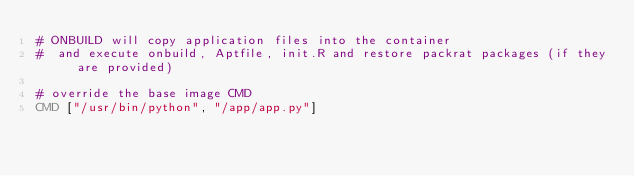<code> <loc_0><loc_0><loc_500><loc_500><_Dockerfile_># ONBUILD will copy application files into the container
#  and execute onbuild, Aptfile, init.R and restore packrat packages (if they are provided)

# override the base image CMD
CMD ["/usr/bin/python", "/app/app.py"]
</code> 